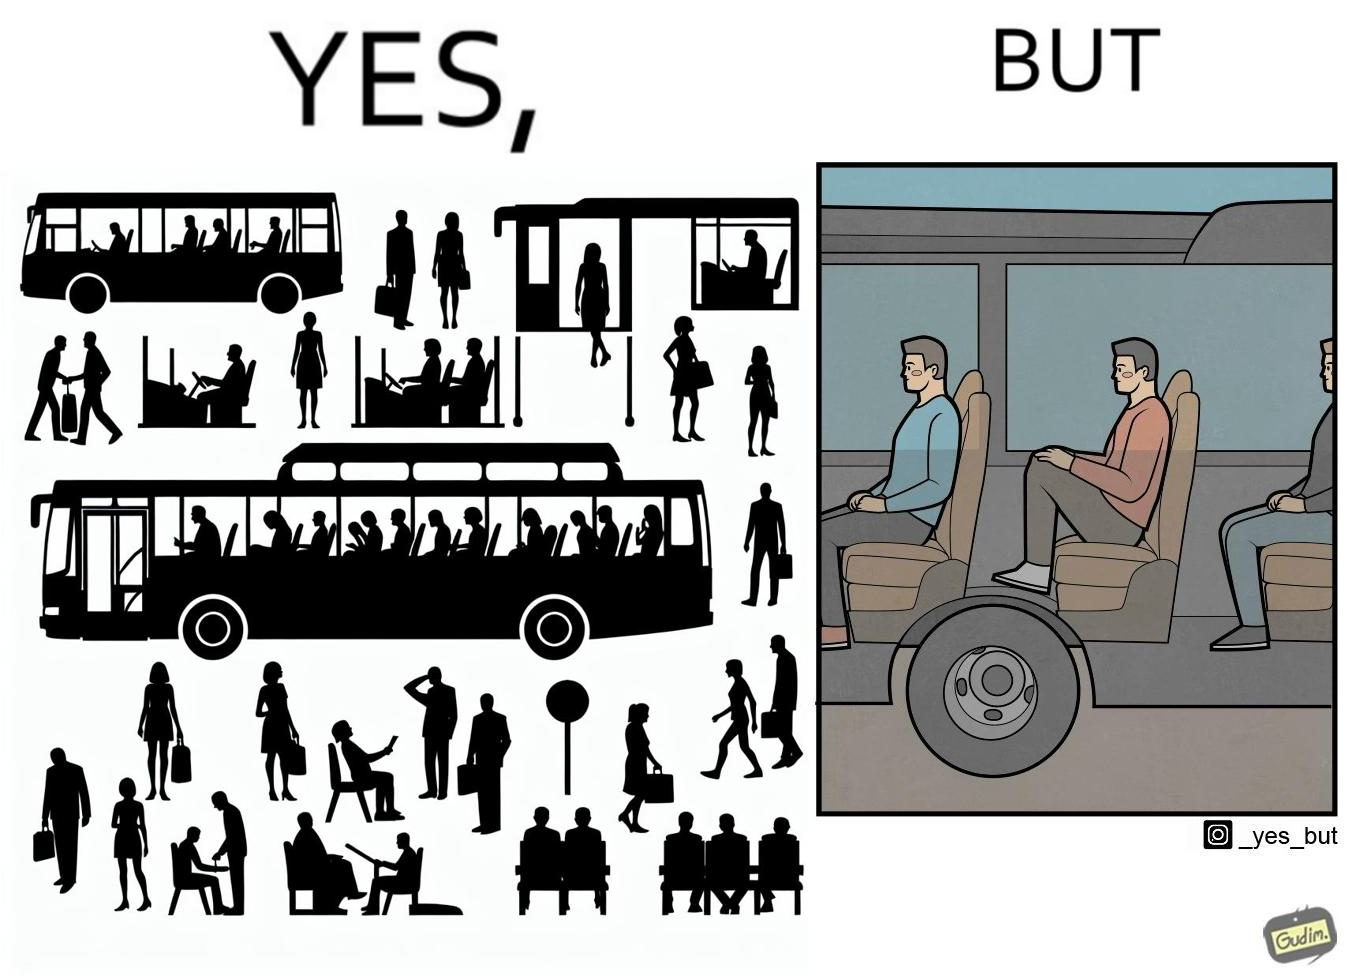Describe the content of this image. the irony in this image is that the seat right above a bus' wheels is the most uncomfortable one. 